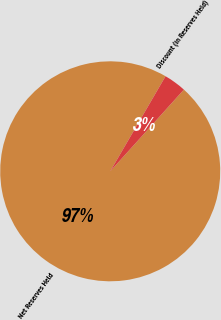Convert chart. <chart><loc_0><loc_0><loc_500><loc_500><pie_chart><fcel>Net Reserves Held<fcel>Discount (in Reserves Held)<nl><fcel>96.71%<fcel>3.29%<nl></chart> 